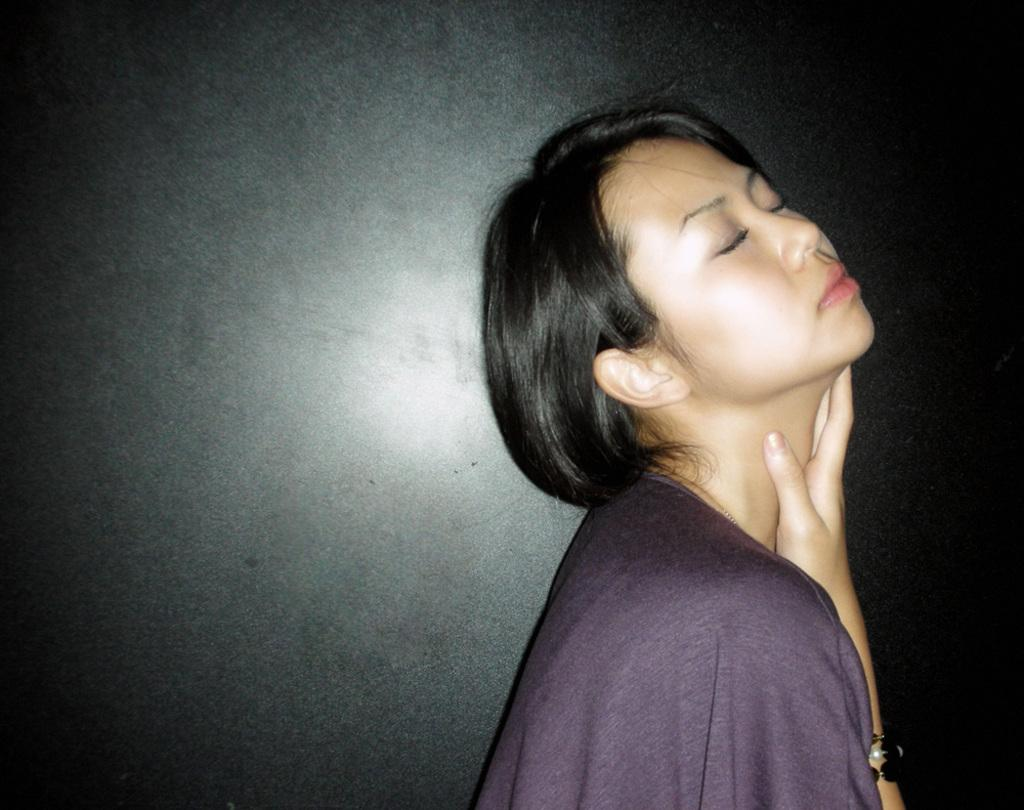Who or what is the main subject in the image? There is a person in the image. What can be seen in the background of the image? There is a wall in the background of the image. What type of twist can be seen in the person's hair in the image? There is no twist visible in the person's hair in the image. 